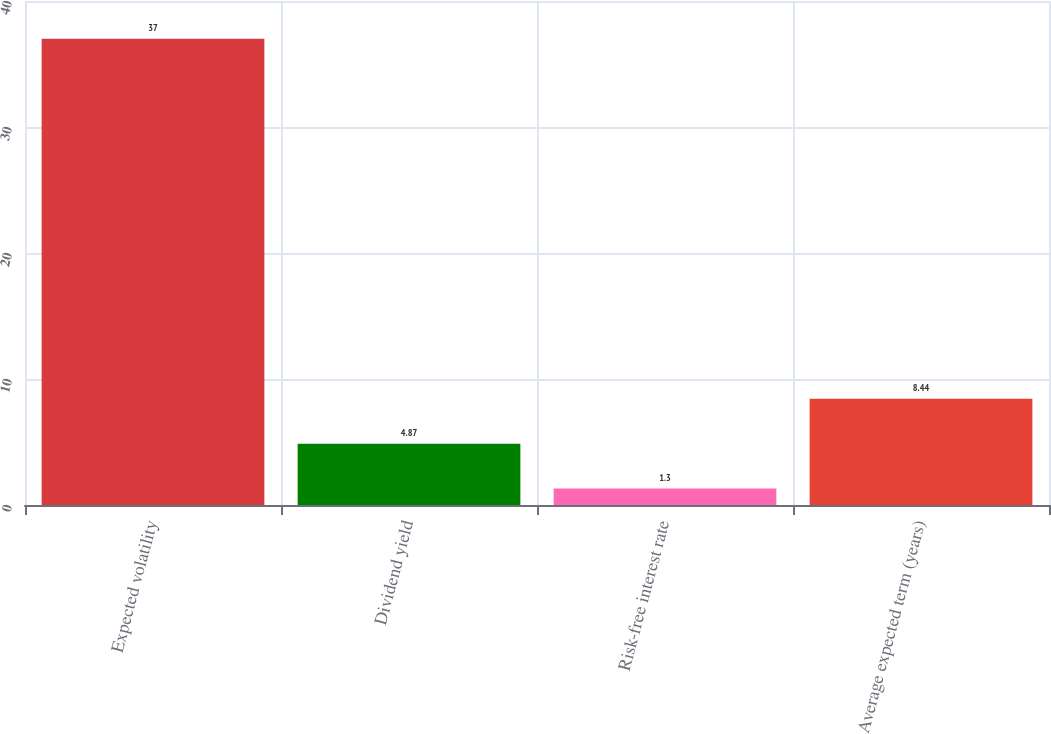<chart> <loc_0><loc_0><loc_500><loc_500><bar_chart><fcel>Expected volatility<fcel>Dividend yield<fcel>Risk-free interest rate<fcel>Average expected term (years)<nl><fcel>37<fcel>4.87<fcel>1.3<fcel>8.44<nl></chart> 